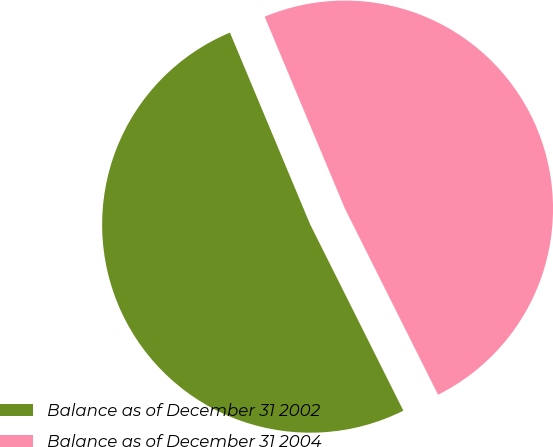Convert chart. <chart><loc_0><loc_0><loc_500><loc_500><pie_chart><fcel>Balance as of December 31 2002<fcel>Balance as of December 31 2004<nl><fcel>51.08%<fcel>48.92%<nl></chart> 